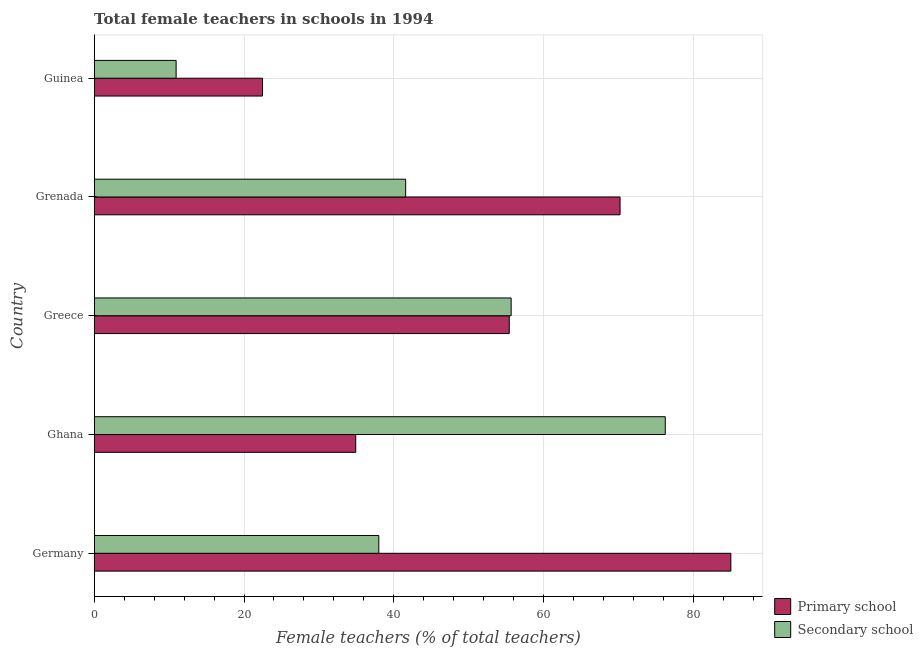How many groups of bars are there?
Offer a very short reply. 5. Are the number of bars per tick equal to the number of legend labels?
Keep it short and to the point. Yes. Are the number of bars on each tick of the Y-axis equal?
Your answer should be very brief. Yes. How many bars are there on the 1st tick from the top?
Keep it short and to the point. 2. What is the label of the 1st group of bars from the top?
Ensure brevity in your answer.  Guinea. What is the percentage of female teachers in primary schools in Germany?
Your answer should be very brief. 85. Across all countries, what is the maximum percentage of female teachers in primary schools?
Your answer should be very brief. 85. Across all countries, what is the minimum percentage of female teachers in secondary schools?
Keep it short and to the point. 10.94. In which country was the percentage of female teachers in primary schools minimum?
Your answer should be compact. Guinea. What is the total percentage of female teachers in secondary schools in the graph?
Make the answer very short. 222.44. What is the difference between the percentage of female teachers in primary schools in Ghana and that in Greece?
Provide a short and direct response. -20.5. What is the difference between the percentage of female teachers in primary schools in Grenada and the percentage of female teachers in secondary schools in Germany?
Your response must be concise. 32.21. What is the average percentage of female teachers in secondary schools per country?
Provide a succinct answer. 44.49. What is the difference between the percentage of female teachers in secondary schools and percentage of female teachers in primary schools in Germany?
Offer a very short reply. -47. What is the ratio of the percentage of female teachers in primary schools in Germany to that in Guinea?
Your response must be concise. 3.78. Is the percentage of female teachers in secondary schools in Germany less than that in Grenada?
Keep it short and to the point. Yes. What is the difference between the highest and the second highest percentage of female teachers in primary schools?
Give a very brief answer. 14.79. What is the difference between the highest and the lowest percentage of female teachers in primary schools?
Keep it short and to the point. 62.53. In how many countries, is the percentage of female teachers in secondary schools greater than the average percentage of female teachers in secondary schools taken over all countries?
Your answer should be compact. 2. Is the sum of the percentage of female teachers in primary schools in Germany and Grenada greater than the maximum percentage of female teachers in secondary schools across all countries?
Offer a terse response. Yes. What does the 1st bar from the top in Germany represents?
Your response must be concise. Secondary school. What does the 1st bar from the bottom in Ghana represents?
Your answer should be very brief. Primary school. How many bars are there?
Your answer should be very brief. 10. Are all the bars in the graph horizontal?
Keep it short and to the point. Yes. How many countries are there in the graph?
Your answer should be very brief. 5. What is the difference between two consecutive major ticks on the X-axis?
Keep it short and to the point. 20. Does the graph contain grids?
Make the answer very short. Yes. Where does the legend appear in the graph?
Offer a terse response. Bottom right. How many legend labels are there?
Keep it short and to the point. 2. How are the legend labels stacked?
Provide a short and direct response. Vertical. What is the title of the graph?
Keep it short and to the point. Total female teachers in schools in 1994. Does "Services" appear as one of the legend labels in the graph?
Make the answer very short. No. What is the label or title of the X-axis?
Offer a very short reply. Female teachers (% of total teachers). What is the Female teachers (% of total teachers) in Primary school in Germany?
Your response must be concise. 85. What is the Female teachers (% of total teachers) in Secondary school in Germany?
Provide a succinct answer. 38. What is the Female teachers (% of total teachers) of Primary school in Ghana?
Offer a terse response. 34.92. What is the Female teachers (% of total teachers) of Secondary school in Ghana?
Offer a terse response. 76.24. What is the Female teachers (% of total teachers) in Primary school in Greece?
Make the answer very short. 55.42. What is the Female teachers (% of total teachers) in Secondary school in Greece?
Offer a terse response. 55.67. What is the Female teachers (% of total teachers) in Primary school in Grenada?
Keep it short and to the point. 70.21. What is the Female teachers (% of total teachers) in Secondary school in Grenada?
Keep it short and to the point. 41.59. What is the Female teachers (% of total teachers) in Primary school in Guinea?
Provide a short and direct response. 22.47. What is the Female teachers (% of total teachers) in Secondary school in Guinea?
Offer a very short reply. 10.94. Across all countries, what is the maximum Female teachers (% of total teachers) of Primary school?
Provide a short and direct response. 85. Across all countries, what is the maximum Female teachers (% of total teachers) of Secondary school?
Provide a succinct answer. 76.24. Across all countries, what is the minimum Female teachers (% of total teachers) in Primary school?
Give a very brief answer. 22.47. Across all countries, what is the minimum Female teachers (% of total teachers) of Secondary school?
Provide a succinct answer. 10.94. What is the total Female teachers (% of total teachers) in Primary school in the graph?
Ensure brevity in your answer.  268.02. What is the total Female teachers (% of total teachers) in Secondary school in the graph?
Your answer should be compact. 222.44. What is the difference between the Female teachers (% of total teachers) in Primary school in Germany and that in Ghana?
Your response must be concise. 50.08. What is the difference between the Female teachers (% of total teachers) of Secondary school in Germany and that in Ghana?
Keep it short and to the point. -38.24. What is the difference between the Female teachers (% of total teachers) in Primary school in Germany and that in Greece?
Provide a short and direct response. 29.58. What is the difference between the Female teachers (% of total teachers) in Secondary school in Germany and that in Greece?
Your response must be concise. -17.67. What is the difference between the Female teachers (% of total teachers) in Primary school in Germany and that in Grenada?
Your answer should be compact. 14.79. What is the difference between the Female teachers (% of total teachers) in Secondary school in Germany and that in Grenada?
Your response must be concise. -3.59. What is the difference between the Female teachers (% of total teachers) of Primary school in Germany and that in Guinea?
Provide a succinct answer. 62.53. What is the difference between the Female teachers (% of total teachers) in Secondary school in Germany and that in Guinea?
Your answer should be compact. 27.06. What is the difference between the Female teachers (% of total teachers) of Primary school in Ghana and that in Greece?
Your answer should be compact. -20.5. What is the difference between the Female teachers (% of total teachers) in Secondary school in Ghana and that in Greece?
Ensure brevity in your answer.  20.58. What is the difference between the Female teachers (% of total teachers) of Primary school in Ghana and that in Grenada?
Offer a terse response. -35.29. What is the difference between the Female teachers (% of total teachers) in Secondary school in Ghana and that in Grenada?
Ensure brevity in your answer.  34.66. What is the difference between the Female teachers (% of total teachers) in Primary school in Ghana and that in Guinea?
Make the answer very short. 12.45. What is the difference between the Female teachers (% of total teachers) in Secondary school in Ghana and that in Guinea?
Your response must be concise. 65.31. What is the difference between the Female teachers (% of total teachers) in Primary school in Greece and that in Grenada?
Give a very brief answer. -14.79. What is the difference between the Female teachers (% of total teachers) in Secondary school in Greece and that in Grenada?
Make the answer very short. 14.08. What is the difference between the Female teachers (% of total teachers) of Primary school in Greece and that in Guinea?
Make the answer very short. 32.94. What is the difference between the Female teachers (% of total teachers) of Secondary school in Greece and that in Guinea?
Your answer should be compact. 44.73. What is the difference between the Female teachers (% of total teachers) of Primary school in Grenada and that in Guinea?
Provide a short and direct response. 47.74. What is the difference between the Female teachers (% of total teachers) of Secondary school in Grenada and that in Guinea?
Your answer should be compact. 30.65. What is the difference between the Female teachers (% of total teachers) of Primary school in Germany and the Female teachers (% of total teachers) of Secondary school in Ghana?
Give a very brief answer. 8.76. What is the difference between the Female teachers (% of total teachers) in Primary school in Germany and the Female teachers (% of total teachers) in Secondary school in Greece?
Keep it short and to the point. 29.33. What is the difference between the Female teachers (% of total teachers) of Primary school in Germany and the Female teachers (% of total teachers) of Secondary school in Grenada?
Your answer should be compact. 43.42. What is the difference between the Female teachers (% of total teachers) in Primary school in Germany and the Female teachers (% of total teachers) in Secondary school in Guinea?
Offer a very short reply. 74.06. What is the difference between the Female teachers (% of total teachers) of Primary school in Ghana and the Female teachers (% of total teachers) of Secondary school in Greece?
Your answer should be compact. -20.75. What is the difference between the Female teachers (% of total teachers) of Primary school in Ghana and the Female teachers (% of total teachers) of Secondary school in Grenada?
Offer a terse response. -6.67. What is the difference between the Female teachers (% of total teachers) of Primary school in Ghana and the Female teachers (% of total teachers) of Secondary school in Guinea?
Offer a very short reply. 23.98. What is the difference between the Female teachers (% of total teachers) of Primary school in Greece and the Female teachers (% of total teachers) of Secondary school in Grenada?
Provide a succinct answer. 13.83. What is the difference between the Female teachers (% of total teachers) in Primary school in Greece and the Female teachers (% of total teachers) in Secondary school in Guinea?
Your answer should be very brief. 44.48. What is the difference between the Female teachers (% of total teachers) in Primary school in Grenada and the Female teachers (% of total teachers) in Secondary school in Guinea?
Your answer should be compact. 59.27. What is the average Female teachers (% of total teachers) of Primary school per country?
Ensure brevity in your answer.  53.6. What is the average Female teachers (% of total teachers) of Secondary school per country?
Provide a short and direct response. 44.49. What is the difference between the Female teachers (% of total teachers) in Primary school and Female teachers (% of total teachers) in Secondary school in Germany?
Your answer should be compact. 47. What is the difference between the Female teachers (% of total teachers) in Primary school and Female teachers (% of total teachers) in Secondary school in Ghana?
Ensure brevity in your answer.  -41.33. What is the difference between the Female teachers (% of total teachers) in Primary school and Female teachers (% of total teachers) in Secondary school in Greece?
Ensure brevity in your answer.  -0.25. What is the difference between the Female teachers (% of total teachers) of Primary school and Female teachers (% of total teachers) of Secondary school in Grenada?
Your answer should be compact. 28.62. What is the difference between the Female teachers (% of total teachers) in Primary school and Female teachers (% of total teachers) in Secondary school in Guinea?
Your answer should be compact. 11.53. What is the ratio of the Female teachers (% of total teachers) of Primary school in Germany to that in Ghana?
Give a very brief answer. 2.43. What is the ratio of the Female teachers (% of total teachers) in Secondary school in Germany to that in Ghana?
Make the answer very short. 0.5. What is the ratio of the Female teachers (% of total teachers) of Primary school in Germany to that in Greece?
Provide a short and direct response. 1.53. What is the ratio of the Female teachers (% of total teachers) of Secondary school in Germany to that in Greece?
Your answer should be very brief. 0.68. What is the ratio of the Female teachers (% of total teachers) of Primary school in Germany to that in Grenada?
Make the answer very short. 1.21. What is the ratio of the Female teachers (% of total teachers) in Secondary school in Germany to that in Grenada?
Ensure brevity in your answer.  0.91. What is the ratio of the Female teachers (% of total teachers) of Primary school in Germany to that in Guinea?
Make the answer very short. 3.78. What is the ratio of the Female teachers (% of total teachers) in Secondary school in Germany to that in Guinea?
Your answer should be very brief. 3.47. What is the ratio of the Female teachers (% of total teachers) of Primary school in Ghana to that in Greece?
Your answer should be compact. 0.63. What is the ratio of the Female teachers (% of total teachers) in Secondary school in Ghana to that in Greece?
Keep it short and to the point. 1.37. What is the ratio of the Female teachers (% of total teachers) in Primary school in Ghana to that in Grenada?
Keep it short and to the point. 0.5. What is the ratio of the Female teachers (% of total teachers) of Secondary school in Ghana to that in Grenada?
Offer a terse response. 1.83. What is the ratio of the Female teachers (% of total teachers) of Primary school in Ghana to that in Guinea?
Your answer should be very brief. 1.55. What is the ratio of the Female teachers (% of total teachers) of Secondary school in Ghana to that in Guinea?
Make the answer very short. 6.97. What is the ratio of the Female teachers (% of total teachers) in Primary school in Greece to that in Grenada?
Give a very brief answer. 0.79. What is the ratio of the Female teachers (% of total teachers) of Secondary school in Greece to that in Grenada?
Provide a succinct answer. 1.34. What is the ratio of the Female teachers (% of total teachers) in Primary school in Greece to that in Guinea?
Your answer should be very brief. 2.47. What is the ratio of the Female teachers (% of total teachers) in Secondary school in Greece to that in Guinea?
Give a very brief answer. 5.09. What is the ratio of the Female teachers (% of total teachers) of Primary school in Grenada to that in Guinea?
Offer a terse response. 3.12. What is the ratio of the Female teachers (% of total teachers) of Secondary school in Grenada to that in Guinea?
Ensure brevity in your answer.  3.8. What is the difference between the highest and the second highest Female teachers (% of total teachers) in Primary school?
Your response must be concise. 14.79. What is the difference between the highest and the second highest Female teachers (% of total teachers) of Secondary school?
Keep it short and to the point. 20.58. What is the difference between the highest and the lowest Female teachers (% of total teachers) of Primary school?
Make the answer very short. 62.53. What is the difference between the highest and the lowest Female teachers (% of total teachers) in Secondary school?
Offer a very short reply. 65.31. 